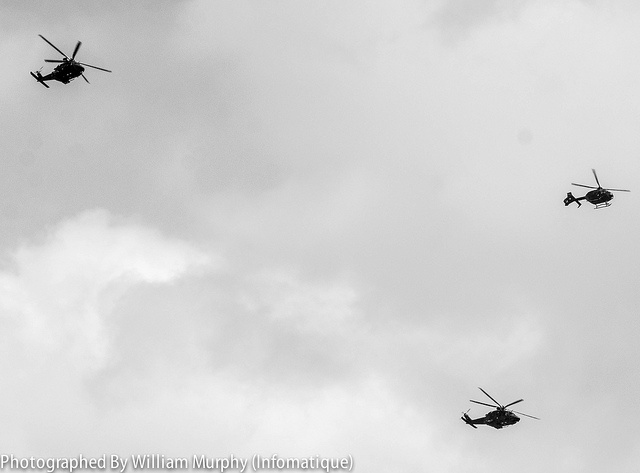Describe the objects in this image and their specific colors. I can see various objects in this image with different colors. 